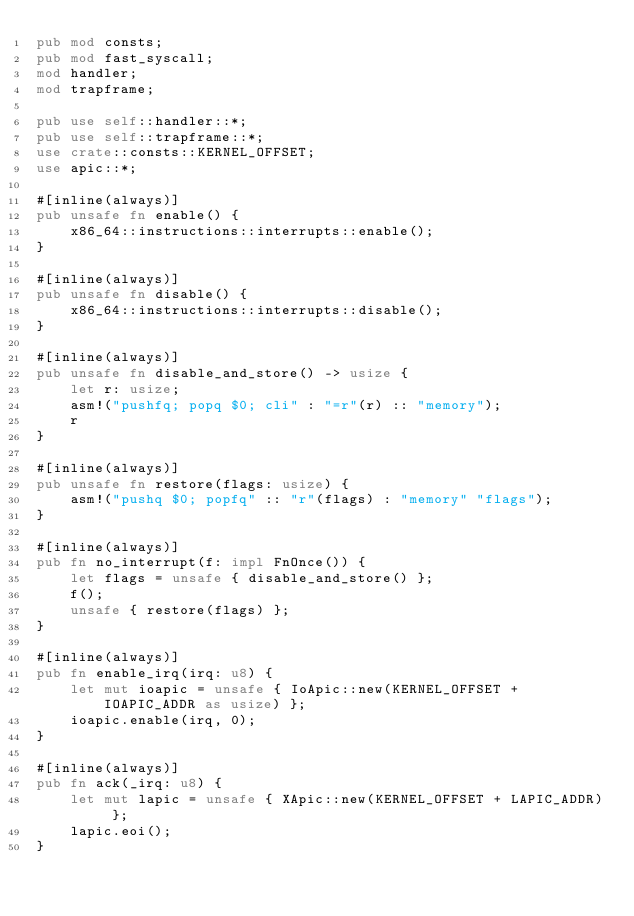Convert code to text. <code><loc_0><loc_0><loc_500><loc_500><_Rust_>pub mod consts;
pub mod fast_syscall;
mod handler;
mod trapframe;

pub use self::handler::*;
pub use self::trapframe::*;
use crate::consts::KERNEL_OFFSET;
use apic::*;

#[inline(always)]
pub unsafe fn enable() {
    x86_64::instructions::interrupts::enable();
}

#[inline(always)]
pub unsafe fn disable() {
    x86_64::instructions::interrupts::disable();
}

#[inline(always)]
pub unsafe fn disable_and_store() -> usize {
    let r: usize;
    asm!("pushfq; popq $0; cli" : "=r"(r) :: "memory");
    r
}

#[inline(always)]
pub unsafe fn restore(flags: usize) {
    asm!("pushq $0; popfq" :: "r"(flags) : "memory" "flags");
}

#[inline(always)]
pub fn no_interrupt(f: impl FnOnce()) {
    let flags = unsafe { disable_and_store() };
    f();
    unsafe { restore(flags) };
}

#[inline(always)]
pub fn enable_irq(irq: u8) {
    let mut ioapic = unsafe { IoApic::new(KERNEL_OFFSET + IOAPIC_ADDR as usize) };
    ioapic.enable(irq, 0);
}

#[inline(always)]
pub fn ack(_irq: u8) {
    let mut lapic = unsafe { XApic::new(KERNEL_OFFSET + LAPIC_ADDR) };
    lapic.eoi();
}
</code> 